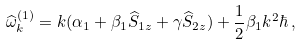<formula> <loc_0><loc_0><loc_500><loc_500>\widehat { \omega } _ { k } ^ { ( 1 ) } = k ( \alpha _ { 1 } + \beta _ { 1 } \widehat { S } _ { 1 z } + \gamma \widehat { S } _ { 2 z } ) + \frac { 1 } { 2 } \beta _ { 1 } k ^ { 2 } \hbar { \, } ,</formula> 